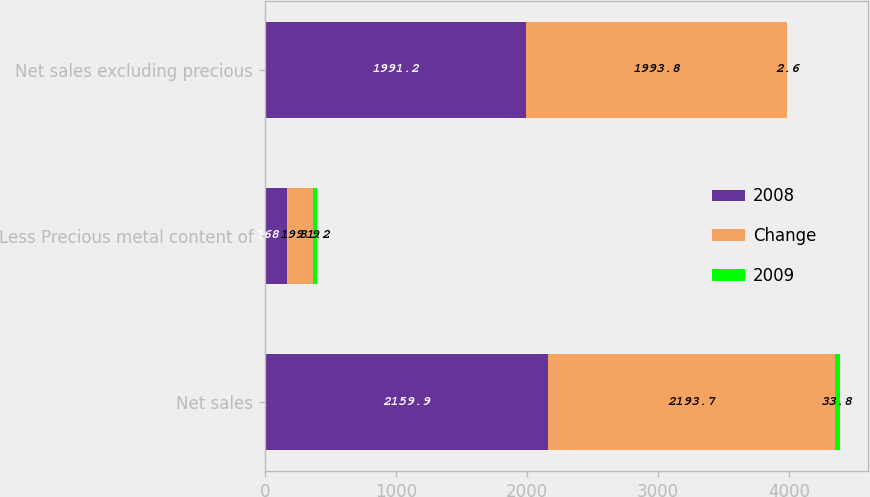Convert chart to OTSL. <chart><loc_0><loc_0><loc_500><loc_500><stacked_bar_chart><ecel><fcel>Net sales<fcel>Less Precious metal content of<fcel>Net sales excluding precious<nl><fcel>2008<fcel>2159.9<fcel>168.7<fcel>1991.2<nl><fcel>Change<fcel>2193.7<fcel>199.9<fcel>1993.8<nl><fcel>2009<fcel>33.8<fcel>31.2<fcel>2.6<nl></chart> 